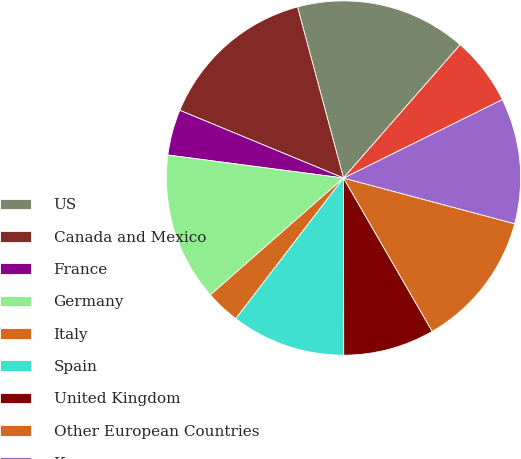Convert chart to OTSL. <chart><loc_0><loc_0><loc_500><loc_500><pie_chart><fcel>US<fcel>Canada and Mexico<fcel>France<fcel>Germany<fcel>Italy<fcel>Spain<fcel>United Kingdom<fcel>Other European Countries<fcel>Korea<fcel>Thailand<nl><fcel>15.62%<fcel>14.58%<fcel>4.17%<fcel>13.54%<fcel>3.13%<fcel>10.42%<fcel>8.33%<fcel>12.5%<fcel>11.46%<fcel>6.25%<nl></chart> 